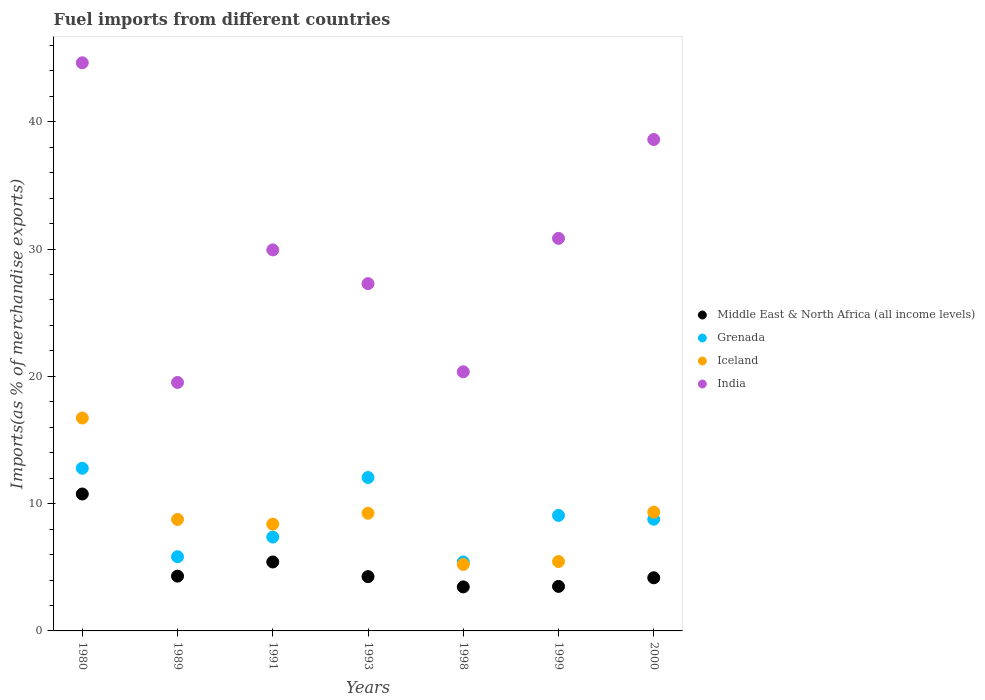How many different coloured dotlines are there?
Your answer should be very brief. 4. Is the number of dotlines equal to the number of legend labels?
Give a very brief answer. Yes. What is the percentage of imports to different countries in Middle East & North Africa (all income levels) in 1980?
Give a very brief answer. 10.76. Across all years, what is the maximum percentage of imports to different countries in Grenada?
Your answer should be compact. 12.78. Across all years, what is the minimum percentage of imports to different countries in Iceland?
Keep it short and to the point. 5.22. In which year was the percentage of imports to different countries in India maximum?
Keep it short and to the point. 1980. In which year was the percentage of imports to different countries in Middle East & North Africa (all income levels) minimum?
Make the answer very short. 1998. What is the total percentage of imports to different countries in Iceland in the graph?
Your answer should be compact. 63.12. What is the difference between the percentage of imports to different countries in Middle East & North Africa (all income levels) in 1998 and that in 2000?
Your answer should be compact. -0.72. What is the difference between the percentage of imports to different countries in Iceland in 1991 and the percentage of imports to different countries in India in 1989?
Your answer should be compact. -11.13. What is the average percentage of imports to different countries in Iceland per year?
Provide a succinct answer. 9.02. In the year 1993, what is the difference between the percentage of imports to different countries in Grenada and percentage of imports to different countries in Middle East & North Africa (all income levels)?
Make the answer very short. 7.78. What is the ratio of the percentage of imports to different countries in Grenada in 1991 to that in 1998?
Provide a succinct answer. 1.36. Is the percentage of imports to different countries in Iceland in 1989 less than that in 2000?
Provide a short and direct response. Yes. Is the difference between the percentage of imports to different countries in Grenada in 1989 and 1991 greater than the difference between the percentage of imports to different countries in Middle East & North Africa (all income levels) in 1989 and 1991?
Provide a short and direct response. No. What is the difference between the highest and the second highest percentage of imports to different countries in Iceland?
Keep it short and to the point. 7.4. What is the difference between the highest and the lowest percentage of imports to different countries in India?
Ensure brevity in your answer.  25.11. In how many years, is the percentage of imports to different countries in Iceland greater than the average percentage of imports to different countries in Iceland taken over all years?
Your answer should be compact. 3. Is the percentage of imports to different countries in Grenada strictly greater than the percentage of imports to different countries in India over the years?
Keep it short and to the point. No. What is the difference between two consecutive major ticks on the Y-axis?
Your answer should be compact. 10. Are the values on the major ticks of Y-axis written in scientific E-notation?
Make the answer very short. No. Where does the legend appear in the graph?
Your response must be concise. Center right. How are the legend labels stacked?
Ensure brevity in your answer.  Vertical. What is the title of the graph?
Provide a succinct answer. Fuel imports from different countries. What is the label or title of the X-axis?
Your response must be concise. Years. What is the label or title of the Y-axis?
Give a very brief answer. Imports(as % of merchandise exports). What is the Imports(as % of merchandise exports) in Middle East & North Africa (all income levels) in 1980?
Provide a succinct answer. 10.76. What is the Imports(as % of merchandise exports) of Grenada in 1980?
Ensure brevity in your answer.  12.78. What is the Imports(as % of merchandise exports) of Iceland in 1980?
Your answer should be compact. 16.73. What is the Imports(as % of merchandise exports) of India in 1980?
Make the answer very short. 44.63. What is the Imports(as % of merchandise exports) of Middle East & North Africa (all income levels) in 1989?
Your answer should be compact. 4.3. What is the Imports(as % of merchandise exports) of Grenada in 1989?
Provide a succinct answer. 5.83. What is the Imports(as % of merchandise exports) of Iceland in 1989?
Give a very brief answer. 8.76. What is the Imports(as % of merchandise exports) of India in 1989?
Provide a succinct answer. 19.52. What is the Imports(as % of merchandise exports) of Middle East & North Africa (all income levels) in 1991?
Your response must be concise. 5.42. What is the Imports(as % of merchandise exports) in Grenada in 1991?
Make the answer very short. 7.37. What is the Imports(as % of merchandise exports) of Iceland in 1991?
Offer a terse response. 8.39. What is the Imports(as % of merchandise exports) in India in 1991?
Offer a terse response. 29.93. What is the Imports(as % of merchandise exports) of Middle East & North Africa (all income levels) in 1993?
Offer a very short reply. 4.27. What is the Imports(as % of merchandise exports) in Grenada in 1993?
Keep it short and to the point. 12.05. What is the Imports(as % of merchandise exports) of Iceland in 1993?
Provide a short and direct response. 9.25. What is the Imports(as % of merchandise exports) in India in 1993?
Make the answer very short. 27.28. What is the Imports(as % of merchandise exports) in Middle East & North Africa (all income levels) in 1998?
Keep it short and to the point. 3.46. What is the Imports(as % of merchandise exports) of Grenada in 1998?
Offer a terse response. 5.42. What is the Imports(as % of merchandise exports) in Iceland in 1998?
Your response must be concise. 5.22. What is the Imports(as % of merchandise exports) in India in 1998?
Keep it short and to the point. 20.36. What is the Imports(as % of merchandise exports) in Middle East & North Africa (all income levels) in 1999?
Your answer should be very brief. 3.5. What is the Imports(as % of merchandise exports) of Grenada in 1999?
Ensure brevity in your answer.  9.08. What is the Imports(as % of merchandise exports) in Iceland in 1999?
Provide a short and direct response. 5.45. What is the Imports(as % of merchandise exports) in India in 1999?
Your answer should be compact. 30.84. What is the Imports(as % of merchandise exports) in Middle East & North Africa (all income levels) in 2000?
Give a very brief answer. 4.17. What is the Imports(as % of merchandise exports) of Grenada in 2000?
Make the answer very short. 8.78. What is the Imports(as % of merchandise exports) in Iceland in 2000?
Offer a very short reply. 9.33. What is the Imports(as % of merchandise exports) in India in 2000?
Provide a succinct answer. 38.6. Across all years, what is the maximum Imports(as % of merchandise exports) in Middle East & North Africa (all income levels)?
Make the answer very short. 10.76. Across all years, what is the maximum Imports(as % of merchandise exports) in Grenada?
Your answer should be compact. 12.78. Across all years, what is the maximum Imports(as % of merchandise exports) in Iceland?
Your answer should be compact. 16.73. Across all years, what is the maximum Imports(as % of merchandise exports) in India?
Give a very brief answer. 44.63. Across all years, what is the minimum Imports(as % of merchandise exports) of Middle East & North Africa (all income levels)?
Provide a short and direct response. 3.46. Across all years, what is the minimum Imports(as % of merchandise exports) of Grenada?
Your response must be concise. 5.42. Across all years, what is the minimum Imports(as % of merchandise exports) of Iceland?
Your response must be concise. 5.22. Across all years, what is the minimum Imports(as % of merchandise exports) of India?
Offer a very short reply. 19.52. What is the total Imports(as % of merchandise exports) in Middle East & North Africa (all income levels) in the graph?
Offer a very short reply. 35.87. What is the total Imports(as % of merchandise exports) of Grenada in the graph?
Give a very brief answer. 61.3. What is the total Imports(as % of merchandise exports) in Iceland in the graph?
Provide a succinct answer. 63.12. What is the total Imports(as % of merchandise exports) in India in the graph?
Your response must be concise. 211.17. What is the difference between the Imports(as % of merchandise exports) in Middle East & North Africa (all income levels) in 1980 and that in 1989?
Your response must be concise. 6.45. What is the difference between the Imports(as % of merchandise exports) of Grenada in 1980 and that in 1989?
Your answer should be compact. 6.95. What is the difference between the Imports(as % of merchandise exports) in Iceland in 1980 and that in 1989?
Your answer should be very brief. 7.97. What is the difference between the Imports(as % of merchandise exports) of India in 1980 and that in 1989?
Provide a succinct answer. 25.11. What is the difference between the Imports(as % of merchandise exports) of Middle East & North Africa (all income levels) in 1980 and that in 1991?
Keep it short and to the point. 5.34. What is the difference between the Imports(as % of merchandise exports) of Grenada in 1980 and that in 1991?
Make the answer very short. 5.41. What is the difference between the Imports(as % of merchandise exports) in Iceland in 1980 and that in 1991?
Ensure brevity in your answer.  8.34. What is the difference between the Imports(as % of merchandise exports) of India in 1980 and that in 1991?
Give a very brief answer. 14.7. What is the difference between the Imports(as % of merchandise exports) in Middle East & North Africa (all income levels) in 1980 and that in 1993?
Offer a very short reply. 6.49. What is the difference between the Imports(as % of merchandise exports) of Grenada in 1980 and that in 1993?
Give a very brief answer. 0.73. What is the difference between the Imports(as % of merchandise exports) of Iceland in 1980 and that in 1993?
Ensure brevity in your answer.  7.48. What is the difference between the Imports(as % of merchandise exports) of India in 1980 and that in 1993?
Make the answer very short. 17.35. What is the difference between the Imports(as % of merchandise exports) of Middle East & North Africa (all income levels) in 1980 and that in 1998?
Ensure brevity in your answer.  7.3. What is the difference between the Imports(as % of merchandise exports) of Grenada in 1980 and that in 1998?
Make the answer very short. 7.36. What is the difference between the Imports(as % of merchandise exports) in Iceland in 1980 and that in 1998?
Make the answer very short. 11.51. What is the difference between the Imports(as % of merchandise exports) in India in 1980 and that in 1998?
Your answer should be very brief. 24.27. What is the difference between the Imports(as % of merchandise exports) in Middle East & North Africa (all income levels) in 1980 and that in 1999?
Give a very brief answer. 7.26. What is the difference between the Imports(as % of merchandise exports) of Grenada in 1980 and that in 1999?
Offer a very short reply. 3.7. What is the difference between the Imports(as % of merchandise exports) of Iceland in 1980 and that in 1999?
Make the answer very short. 11.27. What is the difference between the Imports(as % of merchandise exports) in India in 1980 and that in 1999?
Provide a succinct answer. 13.79. What is the difference between the Imports(as % of merchandise exports) in Middle East & North Africa (all income levels) in 1980 and that in 2000?
Your response must be concise. 6.58. What is the difference between the Imports(as % of merchandise exports) of Grenada in 1980 and that in 2000?
Provide a short and direct response. 4. What is the difference between the Imports(as % of merchandise exports) of Iceland in 1980 and that in 2000?
Your response must be concise. 7.4. What is the difference between the Imports(as % of merchandise exports) in India in 1980 and that in 2000?
Ensure brevity in your answer.  6.03. What is the difference between the Imports(as % of merchandise exports) of Middle East & North Africa (all income levels) in 1989 and that in 1991?
Provide a succinct answer. -1.11. What is the difference between the Imports(as % of merchandise exports) in Grenada in 1989 and that in 1991?
Give a very brief answer. -1.54. What is the difference between the Imports(as % of merchandise exports) in Iceland in 1989 and that in 1991?
Ensure brevity in your answer.  0.37. What is the difference between the Imports(as % of merchandise exports) of India in 1989 and that in 1991?
Your response must be concise. -10.41. What is the difference between the Imports(as % of merchandise exports) of Middle East & North Africa (all income levels) in 1989 and that in 1993?
Provide a succinct answer. 0.04. What is the difference between the Imports(as % of merchandise exports) in Grenada in 1989 and that in 1993?
Ensure brevity in your answer.  -6.22. What is the difference between the Imports(as % of merchandise exports) in Iceland in 1989 and that in 1993?
Offer a terse response. -0.49. What is the difference between the Imports(as % of merchandise exports) of India in 1989 and that in 1993?
Make the answer very short. -7.76. What is the difference between the Imports(as % of merchandise exports) in Middle East & North Africa (all income levels) in 1989 and that in 1998?
Your answer should be compact. 0.85. What is the difference between the Imports(as % of merchandise exports) in Grenada in 1989 and that in 1998?
Make the answer very short. 0.41. What is the difference between the Imports(as % of merchandise exports) in Iceland in 1989 and that in 1998?
Offer a terse response. 3.54. What is the difference between the Imports(as % of merchandise exports) in India in 1989 and that in 1998?
Give a very brief answer. -0.84. What is the difference between the Imports(as % of merchandise exports) in Middle East & North Africa (all income levels) in 1989 and that in 1999?
Offer a very short reply. 0.81. What is the difference between the Imports(as % of merchandise exports) in Grenada in 1989 and that in 1999?
Provide a short and direct response. -3.25. What is the difference between the Imports(as % of merchandise exports) of Iceland in 1989 and that in 1999?
Give a very brief answer. 3.3. What is the difference between the Imports(as % of merchandise exports) in India in 1989 and that in 1999?
Your answer should be very brief. -11.32. What is the difference between the Imports(as % of merchandise exports) of Middle East & North Africa (all income levels) in 1989 and that in 2000?
Your answer should be very brief. 0.13. What is the difference between the Imports(as % of merchandise exports) in Grenada in 1989 and that in 2000?
Keep it short and to the point. -2.95. What is the difference between the Imports(as % of merchandise exports) of Iceland in 1989 and that in 2000?
Your answer should be very brief. -0.57. What is the difference between the Imports(as % of merchandise exports) in India in 1989 and that in 2000?
Your answer should be compact. -19.08. What is the difference between the Imports(as % of merchandise exports) of Middle East & North Africa (all income levels) in 1991 and that in 1993?
Make the answer very short. 1.15. What is the difference between the Imports(as % of merchandise exports) of Grenada in 1991 and that in 1993?
Ensure brevity in your answer.  -4.68. What is the difference between the Imports(as % of merchandise exports) of Iceland in 1991 and that in 1993?
Ensure brevity in your answer.  -0.86. What is the difference between the Imports(as % of merchandise exports) of India in 1991 and that in 1993?
Offer a terse response. 2.65. What is the difference between the Imports(as % of merchandise exports) in Middle East & North Africa (all income levels) in 1991 and that in 1998?
Your answer should be compact. 1.96. What is the difference between the Imports(as % of merchandise exports) of Grenada in 1991 and that in 1998?
Make the answer very short. 1.96. What is the difference between the Imports(as % of merchandise exports) of Iceland in 1991 and that in 1998?
Give a very brief answer. 3.17. What is the difference between the Imports(as % of merchandise exports) of India in 1991 and that in 1998?
Your response must be concise. 9.57. What is the difference between the Imports(as % of merchandise exports) of Middle East & North Africa (all income levels) in 1991 and that in 1999?
Offer a terse response. 1.92. What is the difference between the Imports(as % of merchandise exports) in Grenada in 1991 and that in 1999?
Offer a very short reply. -1.7. What is the difference between the Imports(as % of merchandise exports) of Iceland in 1991 and that in 1999?
Your response must be concise. 2.93. What is the difference between the Imports(as % of merchandise exports) of India in 1991 and that in 1999?
Provide a succinct answer. -0.91. What is the difference between the Imports(as % of merchandise exports) of Middle East & North Africa (all income levels) in 1991 and that in 2000?
Give a very brief answer. 1.24. What is the difference between the Imports(as % of merchandise exports) of Grenada in 1991 and that in 2000?
Keep it short and to the point. -1.4. What is the difference between the Imports(as % of merchandise exports) in Iceland in 1991 and that in 2000?
Provide a short and direct response. -0.94. What is the difference between the Imports(as % of merchandise exports) in India in 1991 and that in 2000?
Your answer should be compact. -8.67. What is the difference between the Imports(as % of merchandise exports) in Middle East & North Africa (all income levels) in 1993 and that in 1998?
Provide a succinct answer. 0.81. What is the difference between the Imports(as % of merchandise exports) in Grenada in 1993 and that in 1998?
Provide a succinct answer. 6.63. What is the difference between the Imports(as % of merchandise exports) in Iceland in 1993 and that in 1998?
Ensure brevity in your answer.  4.03. What is the difference between the Imports(as % of merchandise exports) of India in 1993 and that in 1998?
Your answer should be very brief. 6.92. What is the difference between the Imports(as % of merchandise exports) of Middle East & North Africa (all income levels) in 1993 and that in 1999?
Make the answer very short. 0.77. What is the difference between the Imports(as % of merchandise exports) in Grenada in 1993 and that in 1999?
Keep it short and to the point. 2.98. What is the difference between the Imports(as % of merchandise exports) in Iceland in 1993 and that in 1999?
Your answer should be very brief. 3.79. What is the difference between the Imports(as % of merchandise exports) in India in 1993 and that in 1999?
Offer a terse response. -3.56. What is the difference between the Imports(as % of merchandise exports) in Middle East & North Africa (all income levels) in 1993 and that in 2000?
Give a very brief answer. 0.09. What is the difference between the Imports(as % of merchandise exports) of Grenada in 1993 and that in 2000?
Provide a short and direct response. 3.27. What is the difference between the Imports(as % of merchandise exports) of Iceland in 1993 and that in 2000?
Give a very brief answer. -0.08. What is the difference between the Imports(as % of merchandise exports) in India in 1993 and that in 2000?
Your answer should be very brief. -11.32. What is the difference between the Imports(as % of merchandise exports) of Middle East & North Africa (all income levels) in 1998 and that in 1999?
Provide a short and direct response. -0.04. What is the difference between the Imports(as % of merchandise exports) of Grenada in 1998 and that in 1999?
Ensure brevity in your answer.  -3.66. What is the difference between the Imports(as % of merchandise exports) in Iceland in 1998 and that in 1999?
Give a very brief answer. -0.23. What is the difference between the Imports(as % of merchandise exports) in India in 1998 and that in 1999?
Your answer should be compact. -10.48. What is the difference between the Imports(as % of merchandise exports) of Middle East & North Africa (all income levels) in 1998 and that in 2000?
Keep it short and to the point. -0.72. What is the difference between the Imports(as % of merchandise exports) in Grenada in 1998 and that in 2000?
Provide a succinct answer. -3.36. What is the difference between the Imports(as % of merchandise exports) of Iceland in 1998 and that in 2000?
Offer a very short reply. -4.11. What is the difference between the Imports(as % of merchandise exports) in India in 1998 and that in 2000?
Offer a terse response. -18.24. What is the difference between the Imports(as % of merchandise exports) of Middle East & North Africa (all income levels) in 1999 and that in 2000?
Offer a very short reply. -0.68. What is the difference between the Imports(as % of merchandise exports) in Grenada in 1999 and that in 2000?
Your answer should be compact. 0.3. What is the difference between the Imports(as % of merchandise exports) of Iceland in 1999 and that in 2000?
Your answer should be compact. -3.88. What is the difference between the Imports(as % of merchandise exports) in India in 1999 and that in 2000?
Provide a succinct answer. -7.76. What is the difference between the Imports(as % of merchandise exports) in Middle East & North Africa (all income levels) in 1980 and the Imports(as % of merchandise exports) in Grenada in 1989?
Make the answer very short. 4.93. What is the difference between the Imports(as % of merchandise exports) in Middle East & North Africa (all income levels) in 1980 and the Imports(as % of merchandise exports) in Iceland in 1989?
Your answer should be compact. 2. What is the difference between the Imports(as % of merchandise exports) of Middle East & North Africa (all income levels) in 1980 and the Imports(as % of merchandise exports) of India in 1989?
Your answer should be very brief. -8.76. What is the difference between the Imports(as % of merchandise exports) of Grenada in 1980 and the Imports(as % of merchandise exports) of Iceland in 1989?
Your response must be concise. 4.02. What is the difference between the Imports(as % of merchandise exports) in Grenada in 1980 and the Imports(as % of merchandise exports) in India in 1989?
Offer a very short reply. -6.74. What is the difference between the Imports(as % of merchandise exports) of Iceland in 1980 and the Imports(as % of merchandise exports) of India in 1989?
Provide a short and direct response. -2.79. What is the difference between the Imports(as % of merchandise exports) in Middle East & North Africa (all income levels) in 1980 and the Imports(as % of merchandise exports) in Grenada in 1991?
Ensure brevity in your answer.  3.38. What is the difference between the Imports(as % of merchandise exports) in Middle East & North Africa (all income levels) in 1980 and the Imports(as % of merchandise exports) in Iceland in 1991?
Keep it short and to the point. 2.37. What is the difference between the Imports(as % of merchandise exports) of Middle East & North Africa (all income levels) in 1980 and the Imports(as % of merchandise exports) of India in 1991?
Your response must be concise. -19.18. What is the difference between the Imports(as % of merchandise exports) of Grenada in 1980 and the Imports(as % of merchandise exports) of Iceland in 1991?
Offer a terse response. 4.39. What is the difference between the Imports(as % of merchandise exports) of Grenada in 1980 and the Imports(as % of merchandise exports) of India in 1991?
Keep it short and to the point. -17.15. What is the difference between the Imports(as % of merchandise exports) of Iceland in 1980 and the Imports(as % of merchandise exports) of India in 1991?
Your answer should be very brief. -13.21. What is the difference between the Imports(as % of merchandise exports) of Middle East & North Africa (all income levels) in 1980 and the Imports(as % of merchandise exports) of Grenada in 1993?
Ensure brevity in your answer.  -1.29. What is the difference between the Imports(as % of merchandise exports) in Middle East & North Africa (all income levels) in 1980 and the Imports(as % of merchandise exports) in Iceland in 1993?
Make the answer very short. 1.51. What is the difference between the Imports(as % of merchandise exports) of Middle East & North Africa (all income levels) in 1980 and the Imports(as % of merchandise exports) of India in 1993?
Your answer should be compact. -16.53. What is the difference between the Imports(as % of merchandise exports) in Grenada in 1980 and the Imports(as % of merchandise exports) in Iceland in 1993?
Offer a terse response. 3.53. What is the difference between the Imports(as % of merchandise exports) in Grenada in 1980 and the Imports(as % of merchandise exports) in India in 1993?
Offer a very short reply. -14.5. What is the difference between the Imports(as % of merchandise exports) of Iceland in 1980 and the Imports(as % of merchandise exports) of India in 1993?
Your response must be concise. -10.56. What is the difference between the Imports(as % of merchandise exports) in Middle East & North Africa (all income levels) in 1980 and the Imports(as % of merchandise exports) in Grenada in 1998?
Provide a succinct answer. 5.34. What is the difference between the Imports(as % of merchandise exports) in Middle East & North Africa (all income levels) in 1980 and the Imports(as % of merchandise exports) in Iceland in 1998?
Make the answer very short. 5.53. What is the difference between the Imports(as % of merchandise exports) in Middle East & North Africa (all income levels) in 1980 and the Imports(as % of merchandise exports) in India in 1998?
Ensure brevity in your answer.  -9.6. What is the difference between the Imports(as % of merchandise exports) in Grenada in 1980 and the Imports(as % of merchandise exports) in Iceland in 1998?
Offer a terse response. 7.56. What is the difference between the Imports(as % of merchandise exports) of Grenada in 1980 and the Imports(as % of merchandise exports) of India in 1998?
Offer a very short reply. -7.58. What is the difference between the Imports(as % of merchandise exports) in Iceland in 1980 and the Imports(as % of merchandise exports) in India in 1998?
Make the answer very short. -3.63. What is the difference between the Imports(as % of merchandise exports) in Middle East & North Africa (all income levels) in 1980 and the Imports(as % of merchandise exports) in Grenada in 1999?
Provide a succinct answer. 1.68. What is the difference between the Imports(as % of merchandise exports) in Middle East & North Africa (all income levels) in 1980 and the Imports(as % of merchandise exports) in Iceland in 1999?
Ensure brevity in your answer.  5.3. What is the difference between the Imports(as % of merchandise exports) in Middle East & North Africa (all income levels) in 1980 and the Imports(as % of merchandise exports) in India in 1999?
Your answer should be very brief. -20.08. What is the difference between the Imports(as % of merchandise exports) of Grenada in 1980 and the Imports(as % of merchandise exports) of Iceland in 1999?
Make the answer very short. 7.33. What is the difference between the Imports(as % of merchandise exports) of Grenada in 1980 and the Imports(as % of merchandise exports) of India in 1999?
Make the answer very short. -18.06. What is the difference between the Imports(as % of merchandise exports) in Iceland in 1980 and the Imports(as % of merchandise exports) in India in 1999?
Offer a terse response. -14.11. What is the difference between the Imports(as % of merchandise exports) in Middle East & North Africa (all income levels) in 1980 and the Imports(as % of merchandise exports) in Grenada in 2000?
Offer a very short reply. 1.98. What is the difference between the Imports(as % of merchandise exports) in Middle East & North Africa (all income levels) in 1980 and the Imports(as % of merchandise exports) in Iceland in 2000?
Your answer should be very brief. 1.42. What is the difference between the Imports(as % of merchandise exports) of Middle East & North Africa (all income levels) in 1980 and the Imports(as % of merchandise exports) of India in 2000?
Your response must be concise. -27.85. What is the difference between the Imports(as % of merchandise exports) in Grenada in 1980 and the Imports(as % of merchandise exports) in Iceland in 2000?
Make the answer very short. 3.45. What is the difference between the Imports(as % of merchandise exports) of Grenada in 1980 and the Imports(as % of merchandise exports) of India in 2000?
Make the answer very short. -25.82. What is the difference between the Imports(as % of merchandise exports) of Iceland in 1980 and the Imports(as % of merchandise exports) of India in 2000?
Your answer should be compact. -21.88. What is the difference between the Imports(as % of merchandise exports) in Middle East & North Africa (all income levels) in 1989 and the Imports(as % of merchandise exports) in Grenada in 1991?
Your response must be concise. -3.07. What is the difference between the Imports(as % of merchandise exports) of Middle East & North Africa (all income levels) in 1989 and the Imports(as % of merchandise exports) of Iceland in 1991?
Keep it short and to the point. -4.08. What is the difference between the Imports(as % of merchandise exports) of Middle East & North Africa (all income levels) in 1989 and the Imports(as % of merchandise exports) of India in 1991?
Your answer should be compact. -25.63. What is the difference between the Imports(as % of merchandise exports) in Grenada in 1989 and the Imports(as % of merchandise exports) in Iceland in 1991?
Provide a short and direct response. -2.56. What is the difference between the Imports(as % of merchandise exports) in Grenada in 1989 and the Imports(as % of merchandise exports) in India in 1991?
Provide a succinct answer. -24.1. What is the difference between the Imports(as % of merchandise exports) of Iceland in 1989 and the Imports(as % of merchandise exports) of India in 1991?
Your answer should be compact. -21.18. What is the difference between the Imports(as % of merchandise exports) in Middle East & North Africa (all income levels) in 1989 and the Imports(as % of merchandise exports) in Grenada in 1993?
Provide a short and direct response. -7.75. What is the difference between the Imports(as % of merchandise exports) in Middle East & North Africa (all income levels) in 1989 and the Imports(as % of merchandise exports) in Iceland in 1993?
Give a very brief answer. -4.94. What is the difference between the Imports(as % of merchandise exports) in Middle East & North Africa (all income levels) in 1989 and the Imports(as % of merchandise exports) in India in 1993?
Provide a short and direct response. -22.98. What is the difference between the Imports(as % of merchandise exports) in Grenada in 1989 and the Imports(as % of merchandise exports) in Iceland in 1993?
Ensure brevity in your answer.  -3.42. What is the difference between the Imports(as % of merchandise exports) of Grenada in 1989 and the Imports(as % of merchandise exports) of India in 1993?
Make the answer very short. -21.45. What is the difference between the Imports(as % of merchandise exports) of Iceland in 1989 and the Imports(as % of merchandise exports) of India in 1993?
Make the answer very short. -18.53. What is the difference between the Imports(as % of merchandise exports) of Middle East & North Africa (all income levels) in 1989 and the Imports(as % of merchandise exports) of Grenada in 1998?
Your answer should be very brief. -1.11. What is the difference between the Imports(as % of merchandise exports) in Middle East & North Africa (all income levels) in 1989 and the Imports(as % of merchandise exports) in Iceland in 1998?
Provide a succinct answer. -0.92. What is the difference between the Imports(as % of merchandise exports) in Middle East & North Africa (all income levels) in 1989 and the Imports(as % of merchandise exports) in India in 1998?
Your response must be concise. -16.05. What is the difference between the Imports(as % of merchandise exports) in Grenada in 1989 and the Imports(as % of merchandise exports) in Iceland in 1998?
Provide a succinct answer. 0.61. What is the difference between the Imports(as % of merchandise exports) of Grenada in 1989 and the Imports(as % of merchandise exports) of India in 1998?
Keep it short and to the point. -14.53. What is the difference between the Imports(as % of merchandise exports) in Iceland in 1989 and the Imports(as % of merchandise exports) in India in 1998?
Offer a terse response. -11.6. What is the difference between the Imports(as % of merchandise exports) in Middle East & North Africa (all income levels) in 1989 and the Imports(as % of merchandise exports) in Grenada in 1999?
Your answer should be very brief. -4.77. What is the difference between the Imports(as % of merchandise exports) of Middle East & North Africa (all income levels) in 1989 and the Imports(as % of merchandise exports) of Iceland in 1999?
Give a very brief answer. -1.15. What is the difference between the Imports(as % of merchandise exports) of Middle East & North Africa (all income levels) in 1989 and the Imports(as % of merchandise exports) of India in 1999?
Provide a short and direct response. -26.54. What is the difference between the Imports(as % of merchandise exports) in Grenada in 1989 and the Imports(as % of merchandise exports) in Iceland in 1999?
Your response must be concise. 0.38. What is the difference between the Imports(as % of merchandise exports) of Grenada in 1989 and the Imports(as % of merchandise exports) of India in 1999?
Give a very brief answer. -25.01. What is the difference between the Imports(as % of merchandise exports) of Iceland in 1989 and the Imports(as % of merchandise exports) of India in 1999?
Your answer should be compact. -22.08. What is the difference between the Imports(as % of merchandise exports) in Middle East & North Africa (all income levels) in 1989 and the Imports(as % of merchandise exports) in Grenada in 2000?
Provide a succinct answer. -4.47. What is the difference between the Imports(as % of merchandise exports) of Middle East & North Africa (all income levels) in 1989 and the Imports(as % of merchandise exports) of Iceland in 2000?
Offer a very short reply. -5.03. What is the difference between the Imports(as % of merchandise exports) in Middle East & North Africa (all income levels) in 1989 and the Imports(as % of merchandise exports) in India in 2000?
Your response must be concise. -34.3. What is the difference between the Imports(as % of merchandise exports) in Grenada in 1989 and the Imports(as % of merchandise exports) in Iceland in 2000?
Provide a succinct answer. -3.5. What is the difference between the Imports(as % of merchandise exports) of Grenada in 1989 and the Imports(as % of merchandise exports) of India in 2000?
Give a very brief answer. -32.77. What is the difference between the Imports(as % of merchandise exports) of Iceland in 1989 and the Imports(as % of merchandise exports) of India in 2000?
Your answer should be very brief. -29.85. What is the difference between the Imports(as % of merchandise exports) in Middle East & North Africa (all income levels) in 1991 and the Imports(as % of merchandise exports) in Grenada in 1993?
Offer a very short reply. -6.63. What is the difference between the Imports(as % of merchandise exports) in Middle East & North Africa (all income levels) in 1991 and the Imports(as % of merchandise exports) in Iceland in 1993?
Offer a terse response. -3.83. What is the difference between the Imports(as % of merchandise exports) in Middle East & North Africa (all income levels) in 1991 and the Imports(as % of merchandise exports) in India in 1993?
Keep it short and to the point. -21.87. What is the difference between the Imports(as % of merchandise exports) of Grenada in 1991 and the Imports(as % of merchandise exports) of Iceland in 1993?
Provide a succinct answer. -1.88. What is the difference between the Imports(as % of merchandise exports) in Grenada in 1991 and the Imports(as % of merchandise exports) in India in 1993?
Give a very brief answer. -19.91. What is the difference between the Imports(as % of merchandise exports) in Iceland in 1991 and the Imports(as % of merchandise exports) in India in 1993?
Your answer should be compact. -18.89. What is the difference between the Imports(as % of merchandise exports) of Middle East & North Africa (all income levels) in 1991 and the Imports(as % of merchandise exports) of Grenada in 1998?
Make the answer very short. -0. What is the difference between the Imports(as % of merchandise exports) of Middle East & North Africa (all income levels) in 1991 and the Imports(as % of merchandise exports) of Iceland in 1998?
Ensure brevity in your answer.  0.2. What is the difference between the Imports(as % of merchandise exports) of Middle East & North Africa (all income levels) in 1991 and the Imports(as % of merchandise exports) of India in 1998?
Provide a short and direct response. -14.94. What is the difference between the Imports(as % of merchandise exports) in Grenada in 1991 and the Imports(as % of merchandise exports) in Iceland in 1998?
Keep it short and to the point. 2.15. What is the difference between the Imports(as % of merchandise exports) of Grenada in 1991 and the Imports(as % of merchandise exports) of India in 1998?
Your answer should be very brief. -12.98. What is the difference between the Imports(as % of merchandise exports) of Iceland in 1991 and the Imports(as % of merchandise exports) of India in 1998?
Keep it short and to the point. -11.97. What is the difference between the Imports(as % of merchandise exports) of Middle East & North Africa (all income levels) in 1991 and the Imports(as % of merchandise exports) of Grenada in 1999?
Offer a very short reply. -3.66. What is the difference between the Imports(as % of merchandise exports) in Middle East & North Africa (all income levels) in 1991 and the Imports(as % of merchandise exports) in Iceland in 1999?
Offer a very short reply. -0.04. What is the difference between the Imports(as % of merchandise exports) of Middle East & North Africa (all income levels) in 1991 and the Imports(as % of merchandise exports) of India in 1999?
Make the answer very short. -25.42. What is the difference between the Imports(as % of merchandise exports) in Grenada in 1991 and the Imports(as % of merchandise exports) in Iceland in 1999?
Ensure brevity in your answer.  1.92. What is the difference between the Imports(as % of merchandise exports) of Grenada in 1991 and the Imports(as % of merchandise exports) of India in 1999?
Offer a terse response. -23.47. What is the difference between the Imports(as % of merchandise exports) of Iceland in 1991 and the Imports(as % of merchandise exports) of India in 1999?
Your response must be concise. -22.45. What is the difference between the Imports(as % of merchandise exports) in Middle East & North Africa (all income levels) in 1991 and the Imports(as % of merchandise exports) in Grenada in 2000?
Provide a succinct answer. -3.36. What is the difference between the Imports(as % of merchandise exports) in Middle East & North Africa (all income levels) in 1991 and the Imports(as % of merchandise exports) in Iceland in 2000?
Provide a succinct answer. -3.91. What is the difference between the Imports(as % of merchandise exports) in Middle East & North Africa (all income levels) in 1991 and the Imports(as % of merchandise exports) in India in 2000?
Your answer should be compact. -33.19. What is the difference between the Imports(as % of merchandise exports) in Grenada in 1991 and the Imports(as % of merchandise exports) in Iceland in 2000?
Offer a very short reply. -1.96. What is the difference between the Imports(as % of merchandise exports) in Grenada in 1991 and the Imports(as % of merchandise exports) in India in 2000?
Provide a succinct answer. -31.23. What is the difference between the Imports(as % of merchandise exports) of Iceland in 1991 and the Imports(as % of merchandise exports) of India in 2000?
Provide a succinct answer. -30.22. What is the difference between the Imports(as % of merchandise exports) in Middle East & North Africa (all income levels) in 1993 and the Imports(as % of merchandise exports) in Grenada in 1998?
Offer a terse response. -1.15. What is the difference between the Imports(as % of merchandise exports) in Middle East & North Africa (all income levels) in 1993 and the Imports(as % of merchandise exports) in Iceland in 1998?
Provide a short and direct response. -0.96. What is the difference between the Imports(as % of merchandise exports) in Middle East & North Africa (all income levels) in 1993 and the Imports(as % of merchandise exports) in India in 1998?
Make the answer very short. -16.09. What is the difference between the Imports(as % of merchandise exports) in Grenada in 1993 and the Imports(as % of merchandise exports) in Iceland in 1998?
Keep it short and to the point. 6.83. What is the difference between the Imports(as % of merchandise exports) of Grenada in 1993 and the Imports(as % of merchandise exports) of India in 1998?
Offer a terse response. -8.31. What is the difference between the Imports(as % of merchandise exports) in Iceland in 1993 and the Imports(as % of merchandise exports) in India in 1998?
Your answer should be compact. -11.11. What is the difference between the Imports(as % of merchandise exports) of Middle East & North Africa (all income levels) in 1993 and the Imports(as % of merchandise exports) of Grenada in 1999?
Offer a very short reply. -4.81. What is the difference between the Imports(as % of merchandise exports) of Middle East & North Africa (all income levels) in 1993 and the Imports(as % of merchandise exports) of Iceland in 1999?
Keep it short and to the point. -1.19. What is the difference between the Imports(as % of merchandise exports) of Middle East & North Africa (all income levels) in 1993 and the Imports(as % of merchandise exports) of India in 1999?
Provide a succinct answer. -26.57. What is the difference between the Imports(as % of merchandise exports) of Grenada in 1993 and the Imports(as % of merchandise exports) of Iceland in 1999?
Give a very brief answer. 6.6. What is the difference between the Imports(as % of merchandise exports) of Grenada in 1993 and the Imports(as % of merchandise exports) of India in 1999?
Offer a very short reply. -18.79. What is the difference between the Imports(as % of merchandise exports) in Iceland in 1993 and the Imports(as % of merchandise exports) in India in 1999?
Offer a very short reply. -21.59. What is the difference between the Imports(as % of merchandise exports) in Middle East & North Africa (all income levels) in 1993 and the Imports(as % of merchandise exports) in Grenada in 2000?
Provide a short and direct response. -4.51. What is the difference between the Imports(as % of merchandise exports) in Middle East & North Africa (all income levels) in 1993 and the Imports(as % of merchandise exports) in Iceland in 2000?
Your response must be concise. -5.06. What is the difference between the Imports(as % of merchandise exports) in Middle East & North Africa (all income levels) in 1993 and the Imports(as % of merchandise exports) in India in 2000?
Your answer should be compact. -34.34. What is the difference between the Imports(as % of merchandise exports) in Grenada in 1993 and the Imports(as % of merchandise exports) in Iceland in 2000?
Give a very brief answer. 2.72. What is the difference between the Imports(as % of merchandise exports) in Grenada in 1993 and the Imports(as % of merchandise exports) in India in 2000?
Ensure brevity in your answer.  -26.55. What is the difference between the Imports(as % of merchandise exports) in Iceland in 1993 and the Imports(as % of merchandise exports) in India in 2000?
Provide a short and direct response. -29.35. What is the difference between the Imports(as % of merchandise exports) in Middle East & North Africa (all income levels) in 1998 and the Imports(as % of merchandise exports) in Grenada in 1999?
Provide a succinct answer. -5.62. What is the difference between the Imports(as % of merchandise exports) of Middle East & North Africa (all income levels) in 1998 and the Imports(as % of merchandise exports) of Iceland in 1999?
Keep it short and to the point. -2. What is the difference between the Imports(as % of merchandise exports) of Middle East & North Africa (all income levels) in 1998 and the Imports(as % of merchandise exports) of India in 1999?
Ensure brevity in your answer.  -27.38. What is the difference between the Imports(as % of merchandise exports) of Grenada in 1998 and the Imports(as % of merchandise exports) of Iceland in 1999?
Offer a terse response. -0.04. What is the difference between the Imports(as % of merchandise exports) of Grenada in 1998 and the Imports(as % of merchandise exports) of India in 1999?
Provide a short and direct response. -25.42. What is the difference between the Imports(as % of merchandise exports) of Iceland in 1998 and the Imports(as % of merchandise exports) of India in 1999?
Offer a very short reply. -25.62. What is the difference between the Imports(as % of merchandise exports) of Middle East & North Africa (all income levels) in 1998 and the Imports(as % of merchandise exports) of Grenada in 2000?
Ensure brevity in your answer.  -5.32. What is the difference between the Imports(as % of merchandise exports) in Middle East & North Africa (all income levels) in 1998 and the Imports(as % of merchandise exports) in Iceland in 2000?
Give a very brief answer. -5.87. What is the difference between the Imports(as % of merchandise exports) of Middle East & North Africa (all income levels) in 1998 and the Imports(as % of merchandise exports) of India in 2000?
Give a very brief answer. -35.14. What is the difference between the Imports(as % of merchandise exports) in Grenada in 1998 and the Imports(as % of merchandise exports) in Iceland in 2000?
Your answer should be very brief. -3.91. What is the difference between the Imports(as % of merchandise exports) of Grenada in 1998 and the Imports(as % of merchandise exports) of India in 2000?
Offer a terse response. -33.18. What is the difference between the Imports(as % of merchandise exports) of Iceland in 1998 and the Imports(as % of merchandise exports) of India in 2000?
Your response must be concise. -33.38. What is the difference between the Imports(as % of merchandise exports) of Middle East & North Africa (all income levels) in 1999 and the Imports(as % of merchandise exports) of Grenada in 2000?
Your response must be concise. -5.28. What is the difference between the Imports(as % of merchandise exports) in Middle East & North Africa (all income levels) in 1999 and the Imports(as % of merchandise exports) in Iceland in 2000?
Your answer should be compact. -5.83. What is the difference between the Imports(as % of merchandise exports) in Middle East & North Africa (all income levels) in 1999 and the Imports(as % of merchandise exports) in India in 2000?
Ensure brevity in your answer.  -35.11. What is the difference between the Imports(as % of merchandise exports) of Grenada in 1999 and the Imports(as % of merchandise exports) of Iceland in 2000?
Give a very brief answer. -0.26. What is the difference between the Imports(as % of merchandise exports) in Grenada in 1999 and the Imports(as % of merchandise exports) in India in 2000?
Give a very brief answer. -29.53. What is the difference between the Imports(as % of merchandise exports) in Iceland in 1999 and the Imports(as % of merchandise exports) in India in 2000?
Your answer should be compact. -33.15. What is the average Imports(as % of merchandise exports) in Middle East & North Africa (all income levels) per year?
Your answer should be compact. 5.12. What is the average Imports(as % of merchandise exports) of Grenada per year?
Provide a succinct answer. 8.76. What is the average Imports(as % of merchandise exports) in Iceland per year?
Provide a succinct answer. 9.02. What is the average Imports(as % of merchandise exports) of India per year?
Keep it short and to the point. 30.17. In the year 1980, what is the difference between the Imports(as % of merchandise exports) of Middle East & North Africa (all income levels) and Imports(as % of merchandise exports) of Grenada?
Offer a very short reply. -2.02. In the year 1980, what is the difference between the Imports(as % of merchandise exports) of Middle East & North Africa (all income levels) and Imports(as % of merchandise exports) of Iceland?
Offer a very short reply. -5.97. In the year 1980, what is the difference between the Imports(as % of merchandise exports) in Middle East & North Africa (all income levels) and Imports(as % of merchandise exports) in India?
Provide a succinct answer. -33.88. In the year 1980, what is the difference between the Imports(as % of merchandise exports) in Grenada and Imports(as % of merchandise exports) in Iceland?
Provide a short and direct response. -3.95. In the year 1980, what is the difference between the Imports(as % of merchandise exports) in Grenada and Imports(as % of merchandise exports) in India?
Ensure brevity in your answer.  -31.85. In the year 1980, what is the difference between the Imports(as % of merchandise exports) of Iceland and Imports(as % of merchandise exports) of India?
Your answer should be compact. -27.91. In the year 1989, what is the difference between the Imports(as % of merchandise exports) of Middle East & North Africa (all income levels) and Imports(as % of merchandise exports) of Grenada?
Your answer should be very brief. -1.53. In the year 1989, what is the difference between the Imports(as % of merchandise exports) in Middle East & North Africa (all income levels) and Imports(as % of merchandise exports) in Iceland?
Ensure brevity in your answer.  -4.45. In the year 1989, what is the difference between the Imports(as % of merchandise exports) of Middle East & North Africa (all income levels) and Imports(as % of merchandise exports) of India?
Provide a succinct answer. -15.22. In the year 1989, what is the difference between the Imports(as % of merchandise exports) of Grenada and Imports(as % of merchandise exports) of Iceland?
Keep it short and to the point. -2.93. In the year 1989, what is the difference between the Imports(as % of merchandise exports) of Grenada and Imports(as % of merchandise exports) of India?
Ensure brevity in your answer.  -13.69. In the year 1989, what is the difference between the Imports(as % of merchandise exports) of Iceland and Imports(as % of merchandise exports) of India?
Make the answer very short. -10.76. In the year 1991, what is the difference between the Imports(as % of merchandise exports) in Middle East & North Africa (all income levels) and Imports(as % of merchandise exports) in Grenada?
Give a very brief answer. -1.96. In the year 1991, what is the difference between the Imports(as % of merchandise exports) of Middle East & North Africa (all income levels) and Imports(as % of merchandise exports) of Iceland?
Give a very brief answer. -2.97. In the year 1991, what is the difference between the Imports(as % of merchandise exports) of Middle East & North Africa (all income levels) and Imports(as % of merchandise exports) of India?
Give a very brief answer. -24.52. In the year 1991, what is the difference between the Imports(as % of merchandise exports) in Grenada and Imports(as % of merchandise exports) in Iceland?
Your answer should be very brief. -1.01. In the year 1991, what is the difference between the Imports(as % of merchandise exports) in Grenada and Imports(as % of merchandise exports) in India?
Provide a short and direct response. -22.56. In the year 1991, what is the difference between the Imports(as % of merchandise exports) of Iceland and Imports(as % of merchandise exports) of India?
Provide a short and direct response. -21.55. In the year 1993, what is the difference between the Imports(as % of merchandise exports) in Middle East & North Africa (all income levels) and Imports(as % of merchandise exports) in Grenada?
Your answer should be very brief. -7.78. In the year 1993, what is the difference between the Imports(as % of merchandise exports) of Middle East & North Africa (all income levels) and Imports(as % of merchandise exports) of Iceland?
Give a very brief answer. -4.98. In the year 1993, what is the difference between the Imports(as % of merchandise exports) of Middle East & North Africa (all income levels) and Imports(as % of merchandise exports) of India?
Your answer should be compact. -23.02. In the year 1993, what is the difference between the Imports(as % of merchandise exports) of Grenada and Imports(as % of merchandise exports) of Iceland?
Provide a succinct answer. 2.8. In the year 1993, what is the difference between the Imports(as % of merchandise exports) of Grenada and Imports(as % of merchandise exports) of India?
Provide a succinct answer. -15.23. In the year 1993, what is the difference between the Imports(as % of merchandise exports) of Iceland and Imports(as % of merchandise exports) of India?
Your response must be concise. -18.03. In the year 1998, what is the difference between the Imports(as % of merchandise exports) of Middle East & North Africa (all income levels) and Imports(as % of merchandise exports) of Grenada?
Your answer should be compact. -1.96. In the year 1998, what is the difference between the Imports(as % of merchandise exports) of Middle East & North Africa (all income levels) and Imports(as % of merchandise exports) of Iceland?
Make the answer very short. -1.76. In the year 1998, what is the difference between the Imports(as % of merchandise exports) of Middle East & North Africa (all income levels) and Imports(as % of merchandise exports) of India?
Your answer should be compact. -16.9. In the year 1998, what is the difference between the Imports(as % of merchandise exports) of Grenada and Imports(as % of merchandise exports) of Iceland?
Your response must be concise. 0.2. In the year 1998, what is the difference between the Imports(as % of merchandise exports) of Grenada and Imports(as % of merchandise exports) of India?
Give a very brief answer. -14.94. In the year 1998, what is the difference between the Imports(as % of merchandise exports) of Iceland and Imports(as % of merchandise exports) of India?
Give a very brief answer. -15.14. In the year 1999, what is the difference between the Imports(as % of merchandise exports) in Middle East & North Africa (all income levels) and Imports(as % of merchandise exports) in Grenada?
Provide a short and direct response. -5.58. In the year 1999, what is the difference between the Imports(as % of merchandise exports) of Middle East & North Africa (all income levels) and Imports(as % of merchandise exports) of Iceland?
Your answer should be very brief. -1.96. In the year 1999, what is the difference between the Imports(as % of merchandise exports) in Middle East & North Africa (all income levels) and Imports(as % of merchandise exports) in India?
Your response must be concise. -27.34. In the year 1999, what is the difference between the Imports(as % of merchandise exports) of Grenada and Imports(as % of merchandise exports) of Iceland?
Your answer should be very brief. 3.62. In the year 1999, what is the difference between the Imports(as % of merchandise exports) in Grenada and Imports(as % of merchandise exports) in India?
Your answer should be compact. -21.76. In the year 1999, what is the difference between the Imports(as % of merchandise exports) in Iceland and Imports(as % of merchandise exports) in India?
Ensure brevity in your answer.  -25.39. In the year 2000, what is the difference between the Imports(as % of merchandise exports) of Middle East & North Africa (all income levels) and Imports(as % of merchandise exports) of Grenada?
Provide a short and direct response. -4.6. In the year 2000, what is the difference between the Imports(as % of merchandise exports) in Middle East & North Africa (all income levels) and Imports(as % of merchandise exports) in Iceland?
Offer a very short reply. -5.16. In the year 2000, what is the difference between the Imports(as % of merchandise exports) in Middle East & North Africa (all income levels) and Imports(as % of merchandise exports) in India?
Your answer should be very brief. -34.43. In the year 2000, what is the difference between the Imports(as % of merchandise exports) in Grenada and Imports(as % of merchandise exports) in Iceland?
Offer a terse response. -0.56. In the year 2000, what is the difference between the Imports(as % of merchandise exports) of Grenada and Imports(as % of merchandise exports) of India?
Keep it short and to the point. -29.83. In the year 2000, what is the difference between the Imports(as % of merchandise exports) in Iceland and Imports(as % of merchandise exports) in India?
Provide a short and direct response. -29.27. What is the ratio of the Imports(as % of merchandise exports) of Middle East & North Africa (all income levels) in 1980 to that in 1989?
Your response must be concise. 2.5. What is the ratio of the Imports(as % of merchandise exports) of Grenada in 1980 to that in 1989?
Provide a succinct answer. 2.19. What is the ratio of the Imports(as % of merchandise exports) of Iceland in 1980 to that in 1989?
Provide a short and direct response. 1.91. What is the ratio of the Imports(as % of merchandise exports) of India in 1980 to that in 1989?
Offer a very short reply. 2.29. What is the ratio of the Imports(as % of merchandise exports) in Middle East & North Africa (all income levels) in 1980 to that in 1991?
Provide a succinct answer. 1.99. What is the ratio of the Imports(as % of merchandise exports) in Grenada in 1980 to that in 1991?
Keep it short and to the point. 1.73. What is the ratio of the Imports(as % of merchandise exports) in Iceland in 1980 to that in 1991?
Your answer should be compact. 1.99. What is the ratio of the Imports(as % of merchandise exports) of India in 1980 to that in 1991?
Offer a very short reply. 1.49. What is the ratio of the Imports(as % of merchandise exports) of Middle East & North Africa (all income levels) in 1980 to that in 1993?
Give a very brief answer. 2.52. What is the ratio of the Imports(as % of merchandise exports) of Grenada in 1980 to that in 1993?
Give a very brief answer. 1.06. What is the ratio of the Imports(as % of merchandise exports) of Iceland in 1980 to that in 1993?
Your answer should be compact. 1.81. What is the ratio of the Imports(as % of merchandise exports) in India in 1980 to that in 1993?
Your response must be concise. 1.64. What is the ratio of the Imports(as % of merchandise exports) in Middle East & North Africa (all income levels) in 1980 to that in 1998?
Provide a succinct answer. 3.11. What is the ratio of the Imports(as % of merchandise exports) of Grenada in 1980 to that in 1998?
Your answer should be very brief. 2.36. What is the ratio of the Imports(as % of merchandise exports) in Iceland in 1980 to that in 1998?
Ensure brevity in your answer.  3.2. What is the ratio of the Imports(as % of merchandise exports) of India in 1980 to that in 1998?
Ensure brevity in your answer.  2.19. What is the ratio of the Imports(as % of merchandise exports) of Middle East & North Africa (all income levels) in 1980 to that in 1999?
Provide a succinct answer. 3.08. What is the ratio of the Imports(as % of merchandise exports) in Grenada in 1980 to that in 1999?
Provide a short and direct response. 1.41. What is the ratio of the Imports(as % of merchandise exports) of Iceland in 1980 to that in 1999?
Ensure brevity in your answer.  3.07. What is the ratio of the Imports(as % of merchandise exports) of India in 1980 to that in 1999?
Provide a succinct answer. 1.45. What is the ratio of the Imports(as % of merchandise exports) in Middle East & North Africa (all income levels) in 1980 to that in 2000?
Provide a short and direct response. 2.58. What is the ratio of the Imports(as % of merchandise exports) in Grenada in 1980 to that in 2000?
Offer a terse response. 1.46. What is the ratio of the Imports(as % of merchandise exports) of Iceland in 1980 to that in 2000?
Offer a very short reply. 1.79. What is the ratio of the Imports(as % of merchandise exports) of India in 1980 to that in 2000?
Give a very brief answer. 1.16. What is the ratio of the Imports(as % of merchandise exports) of Middle East & North Africa (all income levels) in 1989 to that in 1991?
Keep it short and to the point. 0.79. What is the ratio of the Imports(as % of merchandise exports) of Grenada in 1989 to that in 1991?
Keep it short and to the point. 0.79. What is the ratio of the Imports(as % of merchandise exports) of Iceland in 1989 to that in 1991?
Make the answer very short. 1.04. What is the ratio of the Imports(as % of merchandise exports) of India in 1989 to that in 1991?
Provide a succinct answer. 0.65. What is the ratio of the Imports(as % of merchandise exports) of Middle East & North Africa (all income levels) in 1989 to that in 1993?
Offer a very short reply. 1.01. What is the ratio of the Imports(as % of merchandise exports) in Grenada in 1989 to that in 1993?
Offer a terse response. 0.48. What is the ratio of the Imports(as % of merchandise exports) in Iceland in 1989 to that in 1993?
Make the answer very short. 0.95. What is the ratio of the Imports(as % of merchandise exports) of India in 1989 to that in 1993?
Offer a terse response. 0.72. What is the ratio of the Imports(as % of merchandise exports) in Middle East & North Africa (all income levels) in 1989 to that in 1998?
Your response must be concise. 1.24. What is the ratio of the Imports(as % of merchandise exports) of Grenada in 1989 to that in 1998?
Make the answer very short. 1.08. What is the ratio of the Imports(as % of merchandise exports) in Iceland in 1989 to that in 1998?
Give a very brief answer. 1.68. What is the ratio of the Imports(as % of merchandise exports) in India in 1989 to that in 1998?
Provide a succinct answer. 0.96. What is the ratio of the Imports(as % of merchandise exports) in Middle East & North Africa (all income levels) in 1989 to that in 1999?
Keep it short and to the point. 1.23. What is the ratio of the Imports(as % of merchandise exports) of Grenada in 1989 to that in 1999?
Offer a very short reply. 0.64. What is the ratio of the Imports(as % of merchandise exports) in Iceland in 1989 to that in 1999?
Offer a terse response. 1.61. What is the ratio of the Imports(as % of merchandise exports) of India in 1989 to that in 1999?
Provide a short and direct response. 0.63. What is the ratio of the Imports(as % of merchandise exports) of Middle East & North Africa (all income levels) in 1989 to that in 2000?
Your answer should be very brief. 1.03. What is the ratio of the Imports(as % of merchandise exports) of Grenada in 1989 to that in 2000?
Keep it short and to the point. 0.66. What is the ratio of the Imports(as % of merchandise exports) of Iceland in 1989 to that in 2000?
Your response must be concise. 0.94. What is the ratio of the Imports(as % of merchandise exports) in India in 1989 to that in 2000?
Offer a terse response. 0.51. What is the ratio of the Imports(as % of merchandise exports) of Middle East & North Africa (all income levels) in 1991 to that in 1993?
Offer a very short reply. 1.27. What is the ratio of the Imports(as % of merchandise exports) of Grenada in 1991 to that in 1993?
Make the answer very short. 0.61. What is the ratio of the Imports(as % of merchandise exports) of Iceland in 1991 to that in 1993?
Provide a short and direct response. 0.91. What is the ratio of the Imports(as % of merchandise exports) of India in 1991 to that in 1993?
Your answer should be compact. 1.1. What is the ratio of the Imports(as % of merchandise exports) in Middle East & North Africa (all income levels) in 1991 to that in 1998?
Your answer should be compact. 1.57. What is the ratio of the Imports(as % of merchandise exports) in Grenada in 1991 to that in 1998?
Keep it short and to the point. 1.36. What is the ratio of the Imports(as % of merchandise exports) in Iceland in 1991 to that in 1998?
Your answer should be very brief. 1.61. What is the ratio of the Imports(as % of merchandise exports) of India in 1991 to that in 1998?
Offer a very short reply. 1.47. What is the ratio of the Imports(as % of merchandise exports) of Middle East & North Africa (all income levels) in 1991 to that in 1999?
Keep it short and to the point. 1.55. What is the ratio of the Imports(as % of merchandise exports) in Grenada in 1991 to that in 1999?
Provide a short and direct response. 0.81. What is the ratio of the Imports(as % of merchandise exports) in Iceland in 1991 to that in 1999?
Ensure brevity in your answer.  1.54. What is the ratio of the Imports(as % of merchandise exports) of India in 1991 to that in 1999?
Provide a short and direct response. 0.97. What is the ratio of the Imports(as % of merchandise exports) in Middle East & North Africa (all income levels) in 1991 to that in 2000?
Provide a short and direct response. 1.3. What is the ratio of the Imports(as % of merchandise exports) of Grenada in 1991 to that in 2000?
Give a very brief answer. 0.84. What is the ratio of the Imports(as % of merchandise exports) of Iceland in 1991 to that in 2000?
Give a very brief answer. 0.9. What is the ratio of the Imports(as % of merchandise exports) in India in 1991 to that in 2000?
Offer a terse response. 0.78. What is the ratio of the Imports(as % of merchandise exports) of Middle East & North Africa (all income levels) in 1993 to that in 1998?
Your response must be concise. 1.23. What is the ratio of the Imports(as % of merchandise exports) of Grenada in 1993 to that in 1998?
Your answer should be very brief. 2.22. What is the ratio of the Imports(as % of merchandise exports) in Iceland in 1993 to that in 1998?
Your response must be concise. 1.77. What is the ratio of the Imports(as % of merchandise exports) of India in 1993 to that in 1998?
Ensure brevity in your answer.  1.34. What is the ratio of the Imports(as % of merchandise exports) in Middle East & North Africa (all income levels) in 1993 to that in 1999?
Your response must be concise. 1.22. What is the ratio of the Imports(as % of merchandise exports) in Grenada in 1993 to that in 1999?
Give a very brief answer. 1.33. What is the ratio of the Imports(as % of merchandise exports) in Iceland in 1993 to that in 1999?
Give a very brief answer. 1.7. What is the ratio of the Imports(as % of merchandise exports) of India in 1993 to that in 1999?
Provide a succinct answer. 0.88. What is the ratio of the Imports(as % of merchandise exports) of Middle East & North Africa (all income levels) in 1993 to that in 2000?
Offer a terse response. 1.02. What is the ratio of the Imports(as % of merchandise exports) in Grenada in 1993 to that in 2000?
Offer a terse response. 1.37. What is the ratio of the Imports(as % of merchandise exports) of India in 1993 to that in 2000?
Provide a succinct answer. 0.71. What is the ratio of the Imports(as % of merchandise exports) of Middle East & North Africa (all income levels) in 1998 to that in 1999?
Offer a terse response. 0.99. What is the ratio of the Imports(as % of merchandise exports) in Grenada in 1998 to that in 1999?
Make the answer very short. 0.6. What is the ratio of the Imports(as % of merchandise exports) of Iceland in 1998 to that in 1999?
Provide a succinct answer. 0.96. What is the ratio of the Imports(as % of merchandise exports) in India in 1998 to that in 1999?
Your response must be concise. 0.66. What is the ratio of the Imports(as % of merchandise exports) in Middle East & North Africa (all income levels) in 1998 to that in 2000?
Make the answer very short. 0.83. What is the ratio of the Imports(as % of merchandise exports) in Grenada in 1998 to that in 2000?
Your answer should be compact. 0.62. What is the ratio of the Imports(as % of merchandise exports) of Iceland in 1998 to that in 2000?
Your response must be concise. 0.56. What is the ratio of the Imports(as % of merchandise exports) of India in 1998 to that in 2000?
Your answer should be very brief. 0.53. What is the ratio of the Imports(as % of merchandise exports) in Middle East & North Africa (all income levels) in 1999 to that in 2000?
Ensure brevity in your answer.  0.84. What is the ratio of the Imports(as % of merchandise exports) of Grenada in 1999 to that in 2000?
Your answer should be very brief. 1.03. What is the ratio of the Imports(as % of merchandise exports) of Iceland in 1999 to that in 2000?
Offer a terse response. 0.58. What is the ratio of the Imports(as % of merchandise exports) in India in 1999 to that in 2000?
Keep it short and to the point. 0.8. What is the difference between the highest and the second highest Imports(as % of merchandise exports) of Middle East & North Africa (all income levels)?
Keep it short and to the point. 5.34. What is the difference between the highest and the second highest Imports(as % of merchandise exports) in Grenada?
Give a very brief answer. 0.73. What is the difference between the highest and the second highest Imports(as % of merchandise exports) of Iceland?
Make the answer very short. 7.4. What is the difference between the highest and the second highest Imports(as % of merchandise exports) of India?
Make the answer very short. 6.03. What is the difference between the highest and the lowest Imports(as % of merchandise exports) in Middle East & North Africa (all income levels)?
Your response must be concise. 7.3. What is the difference between the highest and the lowest Imports(as % of merchandise exports) in Grenada?
Keep it short and to the point. 7.36. What is the difference between the highest and the lowest Imports(as % of merchandise exports) of Iceland?
Your answer should be compact. 11.51. What is the difference between the highest and the lowest Imports(as % of merchandise exports) of India?
Offer a terse response. 25.11. 